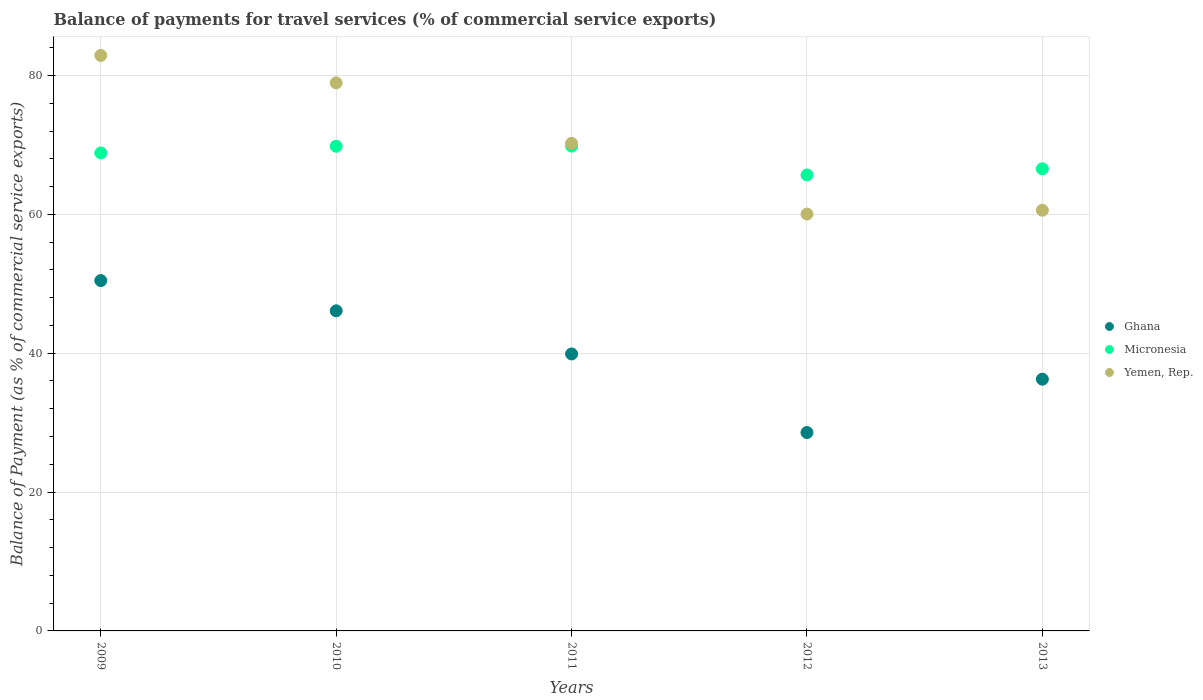What is the balance of payments for travel services in Yemen, Rep. in 2013?
Provide a succinct answer. 60.59. Across all years, what is the maximum balance of payments for travel services in Ghana?
Make the answer very short. 50.46. Across all years, what is the minimum balance of payments for travel services in Yemen, Rep.?
Give a very brief answer. 60.04. In which year was the balance of payments for travel services in Yemen, Rep. maximum?
Provide a succinct answer. 2009. What is the total balance of payments for travel services in Yemen, Rep. in the graph?
Provide a succinct answer. 352.7. What is the difference between the balance of payments for travel services in Yemen, Rep. in 2009 and that in 2012?
Your response must be concise. 22.85. What is the difference between the balance of payments for travel services in Yemen, Rep. in 2010 and the balance of payments for travel services in Micronesia in 2009?
Your answer should be very brief. 10.1. What is the average balance of payments for travel services in Yemen, Rep. per year?
Your answer should be compact. 70.54. In the year 2009, what is the difference between the balance of payments for travel services in Yemen, Rep. and balance of payments for travel services in Ghana?
Your response must be concise. 32.43. In how many years, is the balance of payments for travel services in Yemen, Rep. greater than 40 %?
Provide a succinct answer. 5. What is the ratio of the balance of payments for travel services in Yemen, Rep. in 2010 to that in 2011?
Offer a terse response. 1.12. What is the difference between the highest and the second highest balance of payments for travel services in Micronesia?
Offer a very short reply. 0.03. What is the difference between the highest and the lowest balance of payments for travel services in Ghana?
Make the answer very short. 21.89. Is the sum of the balance of payments for travel services in Yemen, Rep. in 2009 and 2010 greater than the maximum balance of payments for travel services in Micronesia across all years?
Offer a very short reply. Yes. Is the balance of payments for travel services in Ghana strictly less than the balance of payments for travel services in Micronesia over the years?
Ensure brevity in your answer.  Yes. How many dotlines are there?
Make the answer very short. 3. Are the values on the major ticks of Y-axis written in scientific E-notation?
Give a very brief answer. No. Does the graph contain grids?
Provide a short and direct response. Yes. Where does the legend appear in the graph?
Ensure brevity in your answer.  Center right. How are the legend labels stacked?
Make the answer very short. Vertical. What is the title of the graph?
Provide a short and direct response. Balance of payments for travel services (% of commercial service exports). What is the label or title of the Y-axis?
Your response must be concise. Balance of Payment (as % of commercial service exports). What is the Balance of Payment (as % of commercial service exports) of Ghana in 2009?
Make the answer very short. 50.46. What is the Balance of Payment (as % of commercial service exports) in Micronesia in 2009?
Your answer should be very brief. 68.84. What is the Balance of Payment (as % of commercial service exports) of Yemen, Rep. in 2009?
Your answer should be very brief. 82.89. What is the Balance of Payment (as % of commercial service exports) of Ghana in 2010?
Provide a succinct answer. 46.11. What is the Balance of Payment (as % of commercial service exports) in Micronesia in 2010?
Give a very brief answer. 69.81. What is the Balance of Payment (as % of commercial service exports) in Yemen, Rep. in 2010?
Make the answer very short. 78.94. What is the Balance of Payment (as % of commercial service exports) in Ghana in 2011?
Your answer should be very brief. 39.89. What is the Balance of Payment (as % of commercial service exports) of Micronesia in 2011?
Offer a very short reply. 69.84. What is the Balance of Payment (as % of commercial service exports) of Yemen, Rep. in 2011?
Offer a terse response. 70.23. What is the Balance of Payment (as % of commercial service exports) in Ghana in 2012?
Your answer should be very brief. 28.57. What is the Balance of Payment (as % of commercial service exports) in Micronesia in 2012?
Keep it short and to the point. 65.67. What is the Balance of Payment (as % of commercial service exports) in Yemen, Rep. in 2012?
Make the answer very short. 60.04. What is the Balance of Payment (as % of commercial service exports) in Ghana in 2013?
Provide a short and direct response. 36.26. What is the Balance of Payment (as % of commercial service exports) of Micronesia in 2013?
Your response must be concise. 66.57. What is the Balance of Payment (as % of commercial service exports) of Yemen, Rep. in 2013?
Your response must be concise. 60.59. Across all years, what is the maximum Balance of Payment (as % of commercial service exports) of Ghana?
Ensure brevity in your answer.  50.46. Across all years, what is the maximum Balance of Payment (as % of commercial service exports) of Micronesia?
Your answer should be very brief. 69.84. Across all years, what is the maximum Balance of Payment (as % of commercial service exports) in Yemen, Rep.?
Offer a terse response. 82.89. Across all years, what is the minimum Balance of Payment (as % of commercial service exports) in Ghana?
Your answer should be very brief. 28.57. Across all years, what is the minimum Balance of Payment (as % of commercial service exports) in Micronesia?
Provide a short and direct response. 65.67. Across all years, what is the minimum Balance of Payment (as % of commercial service exports) in Yemen, Rep.?
Give a very brief answer. 60.04. What is the total Balance of Payment (as % of commercial service exports) of Ghana in the graph?
Offer a very short reply. 201.3. What is the total Balance of Payment (as % of commercial service exports) in Micronesia in the graph?
Your response must be concise. 340.73. What is the total Balance of Payment (as % of commercial service exports) in Yemen, Rep. in the graph?
Provide a succinct answer. 352.7. What is the difference between the Balance of Payment (as % of commercial service exports) of Ghana in 2009 and that in 2010?
Offer a very short reply. 4.35. What is the difference between the Balance of Payment (as % of commercial service exports) of Micronesia in 2009 and that in 2010?
Provide a succinct answer. -0.97. What is the difference between the Balance of Payment (as % of commercial service exports) of Yemen, Rep. in 2009 and that in 2010?
Make the answer very short. 3.95. What is the difference between the Balance of Payment (as % of commercial service exports) in Ghana in 2009 and that in 2011?
Provide a succinct answer. 10.57. What is the difference between the Balance of Payment (as % of commercial service exports) in Micronesia in 2009 and that in 2011?
Make the answer very short. -0.99. What is the difference between the Balance of Payment (as % of commercial service exports) in Yemen, Rep. in 2009 and that in 2011?
Provide a short and direct response. 12.66. What is the difference between the Balance of Payment (as % of commercial service exports) in Ghana in 2009 and that in 2012?
Your response must be concise. 21.89. What is the difference between the Balance of Payment (as % of commercial service exports) in Micronesia in 2009 and that in 2012?
Ensure brevity in your answer.  3.17. What is the difference between the Balance of Payment (as % of commercial service exports) in Yemen, Rep. in 2009 and that in 2012?
Provide a succinct answer. 22.85. What is the difference between the Balance of Payment (as % of commercial service exports) in Ghana in 2009 and that in 2013?
Your answer should be compact. 14.2. What is the difference between the Balance of Payment (as % of commercial service exports) of Micronesia in 2009 and that in 2013?
Make the answer very short. 2.28. What is the difference between the Balance of Payment (as % of commercial service exports) in Yemen, Rep. in 2009 and that in 2013?
Make the answer very short. 22.3. What is the difference between the Balance of Payment (as % of commercial service exports) in Ghana in 2010 and that in 2011?
Offer a very short reply. 6.21. What is the difference between the Balance of Payment (as % of commercial service exports) in Micronesia in 2010 and that in 2011?
Provide a succinct answer. -0.03. What is the difference between the Balance of Payment (as % of commercial service exports) of Yemen, Rep. in 2010 and that in 2011?
Give a very brief answer. 8.71. What is the difference between the Balance of Payment (as % of commercial service exports) in Ghana in 2010 and that in 2012?
Offer a terse response. 17.53. What is the difference between the Balance of Payment (as % of commercial service exports) in Micronesia in 2010 and that in 2012?
Your answer should be compact. 4.13. What is the difference between the Balance of Payment (as % of commercial service exports) in Yemen, Rep. in 2010 and that in 2012?
Your response must be concise. 18.9. What is the difference between the Balance of Payment (as % of commercial service exports) of Ghana in 2010 and that in 2013?
Offer a terse response. 9.85. What is the difference between the Balance of Payment (as % of commercial service exports) in Micronesia in 2010 and that in 2013?
Give a very brief answer. 3.24. What is the difference between the Balance of Payment (as % of commercial service exports) in Yemen, Rep. in 2010 and that in 2013?
Your answer should be compact. 18.35. What is the difference between the Balance of Payment (as % of commercial service exports) of Ghana in 2011 and that in 2012?
Ensure brevity in your answer.  11.32. What is the difference between the Balance of Payment (as % of commercial service exports) of Micronesia in 2011 and that in 2012?
Your answer should be very brief. 4.16. What is the difference between the Balance of Payment (as % of commercial service exports) of Yemen, Rep. in 2011 and that in 2012?
Offer a very short reply. 10.19. What is the difference between the Balance of Payment (as % of commercial service exports) of Ghana in 2011 and that in 2013?
Your answer should be compact. 3.63. What is the difference between the Balance of Payment (as % of commercial service exports) of Micronesia in 2011 and that in 2013?
Provide a succinct answer. 3.27. What is the difference between the Balance of Payment (as % of commercial service exports) in Yemen, Rep. in 2011 and that in 2013?
Provide a succinct answer. 9.64. What is the difference between the Balance of Payment (as % of commercial service exports) in Ghana in 2012 and that in 2013?
Your answer should be very brief. -7.69. What is the difference between the Balance of Payment (as % of commercial service exports) in Micronesia in 2012 and that in 2013?
Make the answer very short. -0.89. What is the difference between the Balance of Payment (as % of commercial service exports) in Yemen, Rep. in 2012 and that in 2013?
Make the answer very short. -0.55. What is the difference between the Balance of Payment (as % of commercial service exports) in Ghana in 2009 and the Balance of Payment (as % of commercial service exports) in Micronesia in 2010?
Provide a succinct answer. -19.35. What is the difference between the Balance of Payment (as % of commercial service exports) of Ghana in 2009 and the Balance of Payment (as % of commercial service exports) of Yemen, Rep. in 2010?
Give a very brief answer. -28.48. What is the difference between the Balance of Payment (as % of commercial service exports) of Micronesia in 2009 and the Balance of Payment (as % of commercial service exports) of Yemen, Rep. in 2010?
Your answer should be very brief. -10.1. What is the difference between the Balance of Payment (as % of commercial service exports) in Ghana in 2009 and the Balance of Payment (as % of commercial service exports) in Micronesia in 2011?
Provide a succinct answer. -19.37. What is the difference between the Balance of Payment (as % of commercial service exports) of Ghana in 2009 and the Balance of Payment (as % of commercial service exports) of Yemen, Rep. in 2011?
Offer a very short reply. -19.77. What is the difference between the Balance of Payment (as % of commercial service exports) of Micronesia in 2009 and the Balance of Payment (as % of commercial service exports) of Yemen, Rep. in 2011?
Offer a very short reply. -1.39. What is the difference between the Balance of Payment (as % of commercial service exports) in Ghana in 2009 and the Balance of Payment (as % of commercial service exports) in Micronesia in 2012?
Your response must be concise. -15.21. What is the difference between the Balance of Payment (as % of commercial service exports) in Ghana in 2009 and the Balance of Payment (as % of commercial service exports) in Yemen, Rep. in 2012?
Ensure brevity in your answer.  -9.58. What is the difference between the Balance of Payment (as % of commercial service exports) of Micronesia in 2009 and the Balance of Payment (as % of commercial service exports) of Yemen, Rep. in 2012?
Offer a very short reply. 8.8. What is the difference between the Balance of Payment (as % of commercial service exports) in Ghana in 2009 and the Balance of Payment (as % of commercial service exports) in Micronesia in 2013?
Provide a short and direct response. -16.1. What is the difference between the Balance of Payment (as % of commercial service exports) of Ghana in 2009 and the Balance of Payment (as % of commercial service exports) of Yemen, Rep. in 2013?
Offer a very short reply. -10.13. What is the difference between the Balance of Payment (as % of commercial service exports) of Micronesia in 2009 and the Balance of Payment (as % of commercial service exports) of Yemen, Rep. in 2013?
Your response must be concise. 8.25. What is the difference between the Balance of Payment (as % of commercial service exports) in Ghana in 2010 and the Balance of Payment (as % of commercial service exports) in Micronesia in 2011?
Your answer should be compact. -23.73. What is the difference between the Balance of Payment (as % of commercial service exports) of Ghana in 2010 and the Balance of Payment (as % of commercial service exports) of Yemen, Rep. in 2011?
Ensure brevity in your answer.  -24.12. What is the difference between the Balance of Payment (as % of commercial service exports) of Micronesia in 2010 and the Balance of Payment (as % of commercial service exports) of Yemen, Rep. in 2011?
Offer a very short reply. -0.42. What is the difference between the Balance of Payment (as % of commercial service exports) of Ghana in 2010 and the Balance of Payment (as % of commercial service exports) of Micronesia in 2012?
Provide a short and direct response. -19.57. What is the difference between the Balance of Payment (as % of commercial service exports) of Ghana in 2010 and the Balance of Payment (as % of commercial service exports) of Yemen, Rep. in 2012?
Offer a very short reply. -13.94. What is the difference between the Balance of Payment (as % of commercial service exports) in Micronesia in 2010 and the Balance of Payment (as % of commercial service exports) in Yemen, Rep. in 2012?
Offer a terse response. 9.76. What is the difference between the Balance of Payment (as % of commercial service exports) of Ghana in 2010 and the Balance of Payment (as % of commercial service exports) of Micronesia in 2013?
Give a very brief answer. -20.46. What is the difference between the Balance of Payment (as % of commercial service exports) of Ghana in 2010 and the Balance of Payment (as % of commercial service exports) of Yemen, Rep. in 2013?
Make the answer very short. -14.48. What is the difference between the Balance of Payment (as % of commercial service exports) of Micronesia in 2010 and the Balance of Payment (as % of commercial service exports) of Yemen, Rep. in 2013?
Your answer should be compact. 9.22. What is the difference between the Balance of Payment (as % of commercial service exports) in Ghana in 2011 and the Balance of Payment (as % of commercial service exports) in Micronesia in 2012?
Make the answer very short. -25.78. What is the difference between the Balance of Payment (as % of commercial service exports) in Ghana in 2011 and the Balance of Payment (as % of commercial service exports) in Yemen, Rep. in 2012?
Your answer should be very brief. -20.15. What is the difference between the Balance of Payment (as % of commercial service exports) of Micronesia in 2011 and the Balance of Payment (as % of commercial service exports) of Yemen, Rep. in 2012?
Make the answer very short. 9.79. What is the difference between the Balance of Payment (as % of commercial service exports) of Ghana in 2011 and the Balance of Payment (as % of commercial service exports) of Micronesia in 2013?
Offer a very short reply. -26.67. What is the difference between the Balance of Payment (as % of commercial service exports) in Ghana in 2011 and the Balance of Payment (as % of commercial service exports) in Yemen, Rep. in 2013?
Your response must be concise. -20.7. What is the difference between the Balance of Payment (as % of commercial service exports) in Micronesia in 2011 and the Balance of Payment (as % of commercial service exports) in Yemen, Rep. in 2013?
Your answer should be very brief. 9.24. What is the difference between the Balance of Payment (as % of commercial service exports) in Ghana in 2012 and the Balance of Payment (as % of commercial service exports) in Micronesia in 2013?
Your answer should be very brief. -37.99. What is the difference between the Balance of Payment (as % of commercial service exports) in Ghana in 2012 and the Balance of Payment (as % of commercial service exports) in Yemen, Rep. in 2013?
Provide a succinct answer. -32.02. What is the difference between the Balance of Payment (as % of commercial service exports) of Micronesia in 2012 and the Balance of Payment (as % of commercial service exports) of Yemen, Rep. in 2013?
Offer a very short reply. 5.08. What is the average Balance of Payment (as % of commercial service exports) in Ghana per year?
Your response must be concise. 40.26. What is the average Balance of Payment (as % of commercial service exports) in Micronesia per year?
Make the answer very short. 68.15. What is the average Balance of Payment (as % of commercial service exports) of Yemen, Rep. per year?
Keep it short and to the point. 70.54. In the year 2009, what is the difference between the Balance of Payment (as % of commercial service exports) of Ghana and Balance of Payment (as % of commercial service exports) of Micronesia?
Provide a short and direct response. -18.38. In the year 2009, what is the difference between the Balance of Payment (as % of commercial service exports) of Ghana and Balance of Payment (as % of commercial service exports) of Yemen, Rep.?
Your answer should be very brief. -32.43. In the year 2009, what is the difference between the Balance of Payment (as % of commercial service exports) of Micronesia and Balance of Payment (as % of commercial service exports) of Yemen, Rep.?
Your answer should be very brief. -14.05. In the year 2010, what is the difference between the Balance of Payment (as % of commercial service exports) of Ghana and Balance of Payment (as % of commercial service exports) of Micronesia?
Provide a succinct answer. -23.7. In the year 2010, what is the difference between the Balance of Payment (as % of commercial service exports) of Ghana and Balance of Payment (as % of commercial service exports) of Yemen, Rep.?
Provide a succinct answer. -32.83. In the year 2010, what is the difference between the Balance of Payment (as % of commercial service exports) in Micronesia and Balance of Payment (as % of commercial service exports) in Yemen, Rep.?
Ensure brevity in your answer.  -9.13. In the year 2011, what is the difference between the Balance of Payment (as % of commercial service exports) of Ghana and Balance of Payment (as % of commercial service exports) of Micronesia?
Keep it short and to the point. -29.94. In the year 2011, what is the difference between the Balance of Payment (as % of commercial service exports) in Ghana and Balance of Payment (as % of commercial service exports) in Yemen, Rep.?
Keep it short and to the point. -30.34. In the year 2011, what is the difference between the Balance of Payment (as % of commercial service exports) of Micronesia and Balance of Payment (as % of commercial service exports) of Yemen, Rep.?
Give a very brief answer. -0.4. In the year 2012, what is the difference between the Balance of Payment (as % of commercial service exports) in Ghana and Balance of Payment (as % of commercial service exports) in Micronesia?
Keep it short and to the point. -37.1. In the year 2012, what is the difference between the Balance of Payment (as % of commercial service exports) in Ghana and Balance of Payment (as % of commercial service exports) in Yemen, Rep.?
Keep it short and to the point. -31.47. In the year 2012, what is the difference between the Balance of Payment (as % of commercial service exports) of Micronesia and Balance of Payment (as % of commercial service exports) of Yemen, Rep.?
Make the answer very short. 5.63. In the year 2013, what is the difference between the Balance of Payment (as % of commercial service exports) in Ghana and Balance of Payment (as % of commercial service exports) in Micronesia?
Your answer should be compact. -30.31. In the year 2013, what is the difference between the Balance of Payment (as % of commercial service exports) in Ghana and Balance of Payment (as % of commercial service exports) in Yemen, Rep.?
Offer a terse response. -24.33. In the year 2013, what is the difference between the Balance of Payment (as % of commercial service exports) in Micronesia and Balance of Payment (as % of commercial service exports) in Yemen, Rep.?
Offer a very short reply. 5.98. What is the ratio of the Balance of Payment (as % of commercial service exports) of Ghana in 2009 to that in 2010?
Ensure brevity in your answer.  1.09. What is the ratio of the Balance of Payment (as % of commercial service exports) of Micronesia in 2009 to that in 2010?
Offer a terse response. 0.99. What is the ratio of the Balance of Payment (as % of commercial service exports) in Yemen, Rep. in 2009 to that in 2010?
Your answer should be compact. 1.05. What is the ratio of the Balance of Payment (as % of commercial service exports) in Ghana in 2009 to that in 2011?
Ensure brevity in your answer.  1.26. What is the ratio of the Balance of Payment (as % of commercial service exports) in Micronesia in 2009 to that in 2011?
Provide a short and direct response. 0.99. What is the ratio of the Balance of Payment (as % of commercial service exports) in Yemen, Rep. in 2009 to that in 2011?
Your answer should be compact. 1.18. What is the ratio of the Balance of Payment (as % of commercial service exports) of Ghana in 2009 to that in 2012?
Offer a very short reply. 1.77. What is the ratio of the Balance of Payment (as % of commercial service exports) in Micronesia in 2009 to that in 2012?
Offer a terse response. 1.05. What is the ratio of the Balance of Payment (as % of commercial service exports) in Yemen, Rep. in 2009 to that in 2012?
Make the answer very short. 1.38. What is the ratio of the Balance of Payment (as % of commercial service exports) in Ghana in 2009 to that in 2013?
Make the answer very short. 1.39. What is the ratio of the Balance of Payment (as % of commercial service exports) in Micronesia in 2009 to that in 2013?
Make the answer very short. 1.03. What is the ratio of the Balance of Payment (as % of commercial service exports) in Yemen, Rep. in 2009 to that in 2013?
Offer a very short reply. 1.37. What is the ratio of the Balance of Payment (as % of commercial service exports) of Ghana in 2010 to that in 2011?
Your answer should be very brief. 1.16. What is the ratio of the Balance of Payment (as % of commercial service exports) of Micronesia in 2010 to that in 2011?
Ensure brevity in your answer.  1. What is the ratio of the Balance of Payment (as % of commercial service exports) of Yemen, Rep. in 2010 to that in 2011?
Give a very brief answer. 1.12. What is the ratio of the Balance of Payment (as % of commercial service exports) in Ghana in 2010 to that in 2012?
Ensure brevity in your answer.  1.61. What is the ratio of the Balance of Payment (as % of commercial service exports) in Micronesia in 2010 to that in 2012?
Ensure brevity in your answer.  1.06. What is the ratio of the Balance of Payment (as % of commercial service exports) in Yemen, Rep. in 2010 to that in 2012?
Your response must be concise. 1.31. What is the ratio of the Balance of Payment (as % of commercial service exports) in Ghana in 2010 to that in 2013?
Ensure brevity in your answer.  1.27. What is the ratio of the Balance of Payment (as % of commercial service exports) of Micronesia in 2010 to that in 2013?
Offer a terse response. 1.05. What is the ratio of the Balance of Payment (as % of commercial service exports) in Yemen, Rep. in 2010 to that in 2013?
Your answer should be very brief. 1.3. What is the ratio of the Balance of Payment (as % of commercial service exports) in Ghana in 2011 to that in 2012?
Your response must be concise. 1.4. What is the ratio of the Balance of Payment (as % of commercial service exports) in Micronesia in 2011 to that in 2012?
Your answer should be compact. 1.06. What is the ratio of the Balance of Payment (as % of commercial service exports) of Yemen, Rep. in 2011 to that in 2012?
Make the answer very short. 1.17. What is the ratio of the Balance of Payment (as % of commercial service exports) in Ghana in 2011 to that in 2013?
Ensure brevity in your answer.  1.1. What is the ratio of the Balance of Payment (as % of commercial service exports) of Micronesia in 2011 to that in 2013?
Provide a short and direct response. 1.05. What is the ratio of the Balance of Payment (as % of commercial service exports) of Yemen, Rep. in 2011 to that in 2013?
Make the answer very short. 1.16. What is the ratio of the Balance of Payment (as % of commercial service exports) in Ghana in 2012 to that in 2013?
Provide a short and direct response. 0.79. What is the ratio of the Balance of Payment (as % of commercial service exports) in Micronesia in 2012 to that in 2013?
Give a very brief answer. 0.99. What is the difference between the highest and the second highest Balance of Payment (as % of commercial service exports) in Ghana?
Offer a terse response. 4.35. What is the difference between the highest and the second highest Balance of Payment (as % of commercial service exports) in Micronesia?
Provide a succinct answer. 0.03. What is the difference between the highest and the second highest Balance of Payment (as % of commercial service exports) of Yemen, Rep.?
Make the answer very short. 3.95. What is the difference between the highest and the lowest Balance of Payment (as % of commercial service exports) of Ghana?
Give a very brief answer. 21.89. What is the difference between the highest and the lowest Balance of Payment (as % of commercial service exports) in Micronesia?
Offer a very short reply. 4.16. What is the difference between the highest and the lowest Balance of Payment (as % of commercial service exports) in Yemen, Rep.?
Keep it short and to the point. 22.85. 